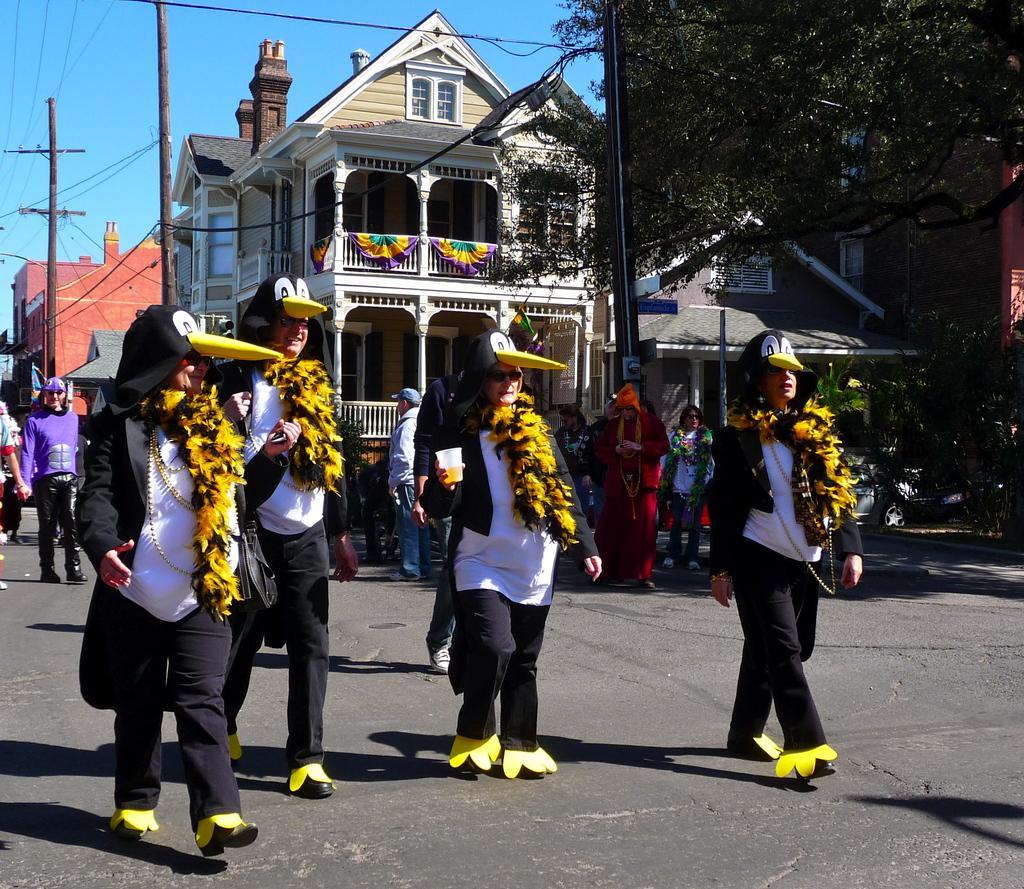Could you give a brief overview of what you see in this image? In this image I can see group of people walking. In front the person is wearing white and black color dress and holding the glass. In the background I can see few electric poles, buildings, trees in green color and the sky is in blue color. 